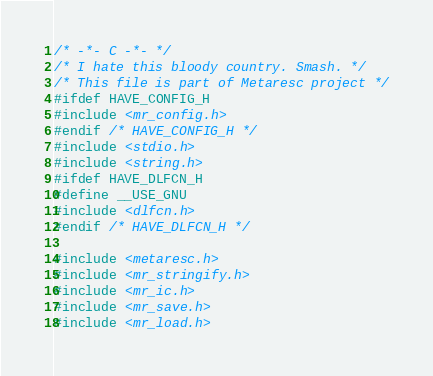<code> <loc_0><loc_0><loc_500><loc_500><_C_>/* -*- C -*- */
/* I hate this bloody country. Smash. */
/* This file is part of Metaresc project */
#ifdef HAVE_CONFIG_H
#include <mr_config.h>
#endif /* HAVE_CONFIG_H */
#include <stdio.h>
#include <string.h>
#ifdef HAVE_DLFCN_H
#define __USE_GNU
#include <dlfcn.h>
#endif /* HAVE_DLFCN_H */

#include <metaresc.h>
#include <mr_stringify.h>
#include <mr_ic.h>
#include <mr_save.h>
#include <mr_load.h></code> 